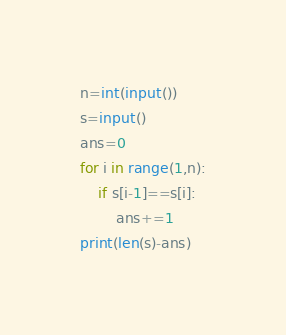Convert code to text. <code><loc_0><loc_0><loc_500><loc_500><_Python_>n=int(input())
s=input()
ans=0
for i in range(1,n):
    if s[i-1]==s[i]:
        ans+=1
print(len(s)-ans)
</code> 